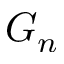Convert formula to latex. <formula><loc_0><loc_0><loc_500><loc_500>G _ { n }</formula> 